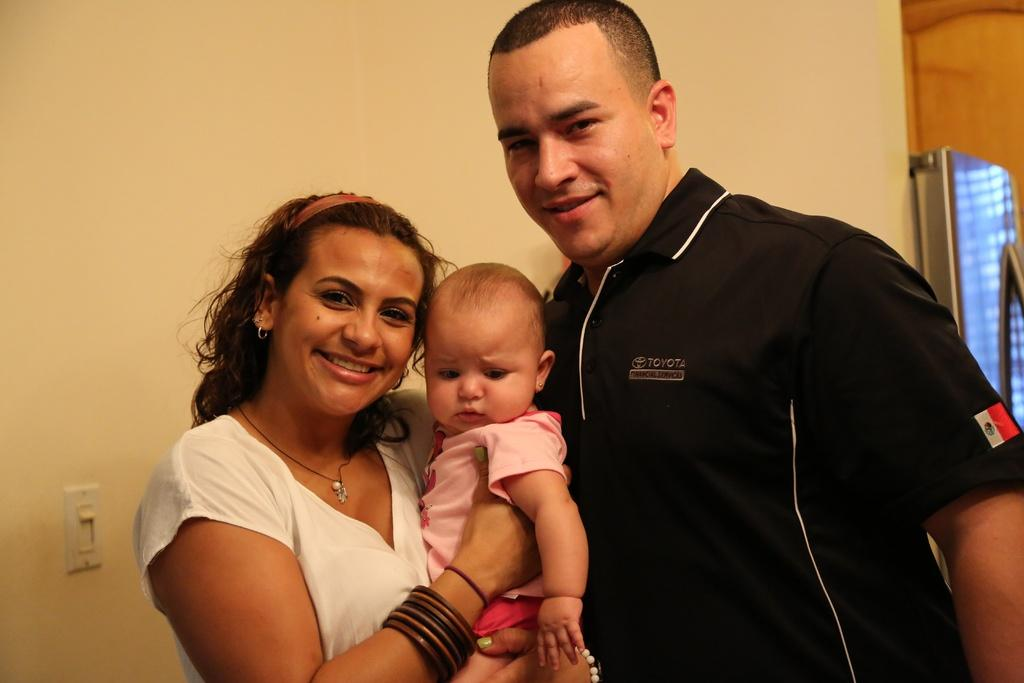<image>
Render a clear and concise summary of the photo. A Toyota employee poses with a woman and child. 